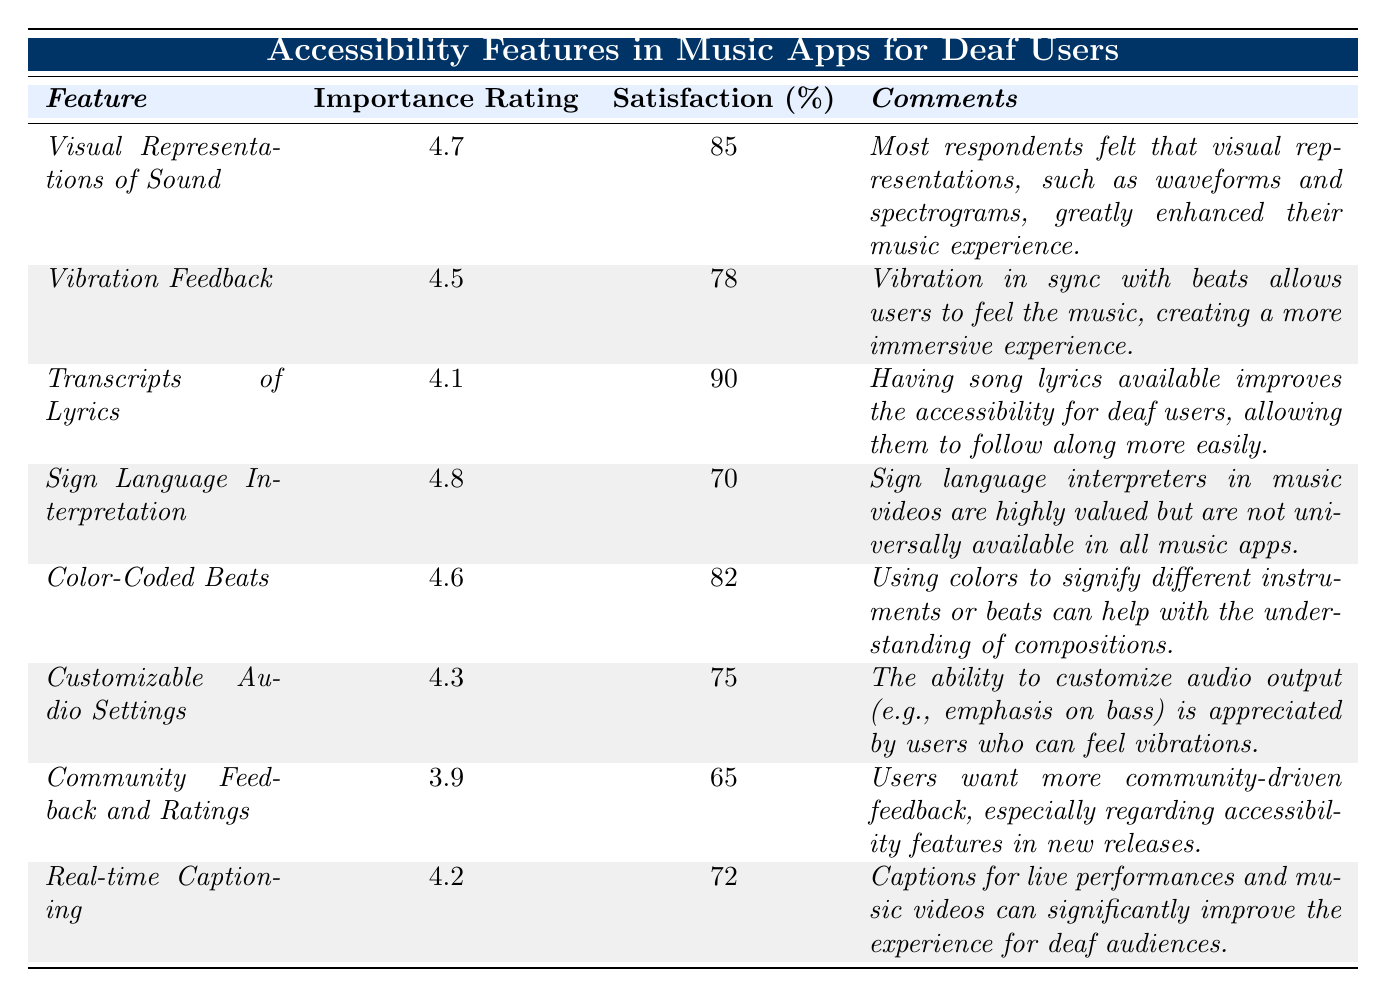What is the highest importance rating among the features? The table lists the importance ratings for each feature. The maximum value is found by comparing all the ratings: 4.7 (Visual Representations of Sound), 4.5 (Vibration Feedback), 4.1 (Transcripts of Lyrics), 4.8 (Sign Language Interpretation), 4.6 (Color-Coded Beats), 4.3 (Customizable Audio Settings), 3.9 (Community Feedback and Ratings), and 4.2 (Real-time Captioning). The highest value is 4.8.
Answer: 4.8 What percentage of users are satisfied with Transcripts of Lyrics? The table indicates the percentage of satisfaction for each feature. For Transcripts of Lyrics, the satisfaction percentage is found directly in the corresponding row of the table, which states 90%.
Answer: 90% Is the percentage of satisfaction for Color-Coded Beats higher than that for Sign Language Interpretation? First, we need to look up the satisfaction percentages for both features. Color-Coded Beats has a satisfaction percentage of 82%, whereas Sign Language Interpretation has 70%. Since 82% is greater than 70%, the answer is yes.
Answer: Yes What is the average importance rating of the features listed in the table? To find the average, we sum the importance ratings of all features: 4.7 + 4.5 + 4.1 + 4.8 + 4.6 + 4.3 + 3.9 + 4.2 = 34.1. There are 8 features, so the average is 34.1 / 8 = 4.2625. Rounding gives approximately 4.26.
Answer: 4.26 Which feature has the lowest percentage of user satisfaction? By examining each satisfaction percentage, we find Community Feedback and Ratings has the lowest percentage at 65%. We confirm this by comparing all the percentages: 85%, 78%, 90%, 70%, 82%, 75%, 65%, and 72%.
Answer: Community Feedback and Ratings If a user values visual representations and vibration feedback equally, which together create an overall score, how would you calculate their combined satisfaction? We take the satisfaction percentages of both Visual Representations of Sound (85%) and Vibration Feedback (78%). The combined score is calculated by adding the two percentages: 85 + 78 = 163, representing the total satisfaction when considering both features.
Answer: 163 How does the importance rating of Real-time Captioning compare to that of Community Feedback and Ratings? We look at the importance ratings for both features. Real-time Captioning has a rating of 4.2, while Community Feedback and Ratings has a rating of 3.9. Since 4.2 is greater than 3.9, Real-time Captioning is more important based on the ratings.
Answer: Real-time Captioning is higher What percentage satisfied users feel that customizable audio settings are valuable? Referring to the table, we find that the percentage of satisfaction for Customizable Audio Settings is listed as 75%. This directly answers the question without any further calculations.
Answer: 75% 